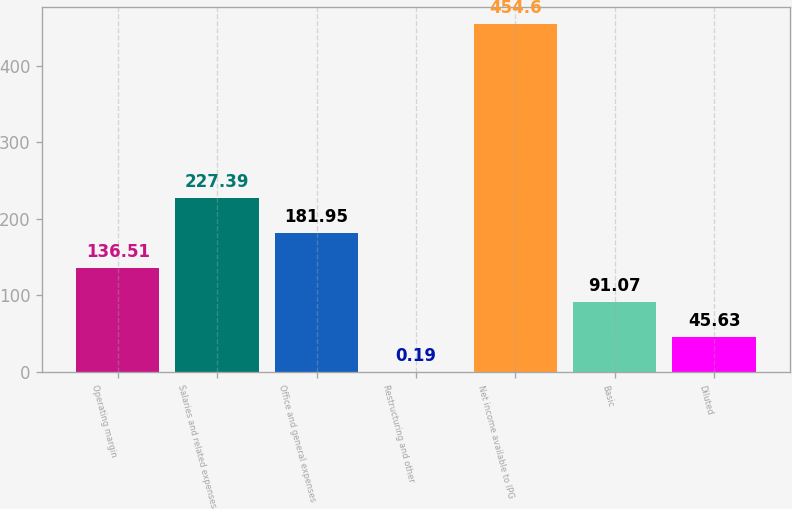<chart> <loc_0><loc_0><loc_500><loc_500><bar_chart><fcel>Operating margin<fcel>Salaries and related expenses<fcel>Office and general expenses<fcel>Restructuring and other<fcel>Net income available to IPG<fcel>Basic<fcel>Diluted<nl><fcel>136.51<fcel>227.39<fcel>181.95<fcel>0.19<fcel>454.6<fcel>91.07<fcel>45.63<nl></chart> 